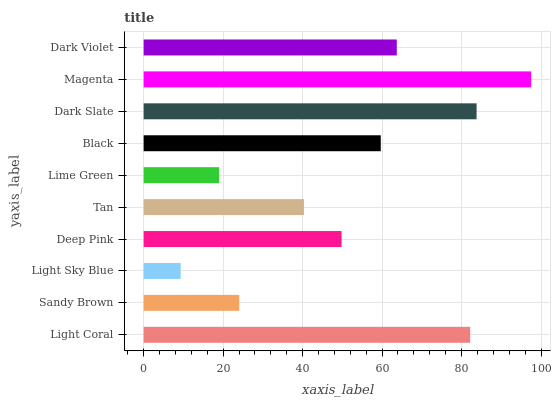Is Light Sky Blue the minimum?
Answer yes or no. Yes. Is Magenta the maximum?
Answer yes or no. Yes. Is Sandy Brown the minimum?
Answer yes or no. No. Is Sandy Brown the maximum?
Answer yes or no. No. Is Light Coral greater than Sandy Brown?
Answer yes or no. Yes. Is Sandy Brown less than Light Coral?
Answer yes or no. Yes. Is Sandy Brown greater than Light Coral?
Answer yes or no. No. Is Light Coral less than Sandy Brown?
Answer yes or no. No. Is Black the high median?
Answer yes or no. Yes. Is Deep Pink the low median?
Answer yes or no. Yes. Is Light Sky Blue the high median?
Answer yes or no. No. Is Lime Green the low median?
Answer yes or no. No. 